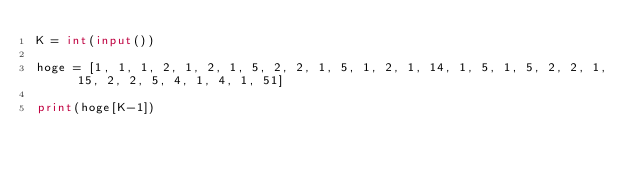<code> <loc_0><loc_0><loc_500><loc_500><_Python_>K = int(input())

hoge = [1, 1, 1, 2, 1, 2, 1, 5, 2, 2, 1, 5, 1, 2, 1, 14, 1, 5, 1, 5, 2, 2, 1, 15, 2, 2, 5, 4, 1, 4, 1, 51]

print(hoge[K-1])</code> 